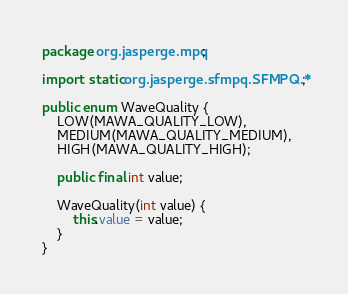Convert code to text. <code><loc_0><loc_0><loc_500><loc_500><_Java_>package org.jasperge.mpq;

import static org.jasperge.sfmpq.SFMPQ.*;

public enum WaveQuality {
    LOW(MAWA_QUALITY_LOW),
    MEDIUM(MAWA_QUALITY_MEDIUM),
    HIGH(MAWA_QUALITY_HIGH);

    public final int value;

    WaveQuality(int value) {
        this.value = value;
    }
}
</code> 